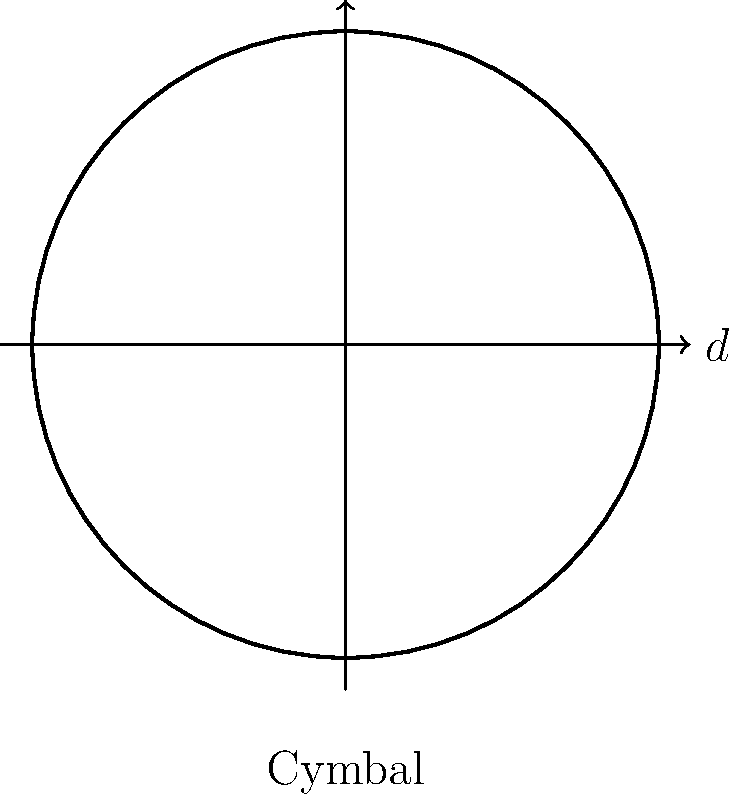Your favorite drummer uses a spherical cymbal with a diameter of 18 inches. Calculate the surface area of this cymbal in square inches. Round your answer to the nearest whole number. To solve this problem, let's follow these steps:

1) First, recall the formula for the surface area of a sphere:
   $$ A = 4\pi r^2 $$
   where $A$ is the surface area and $r$ is the radius.

2) We're given the diameter, which is 18 inches. The radius is half of the diameter:
   $$ r = \frac{d}{2} = \frac{18}{2} = 9 \text{ inches} $$

3) Now, let's substitute this into our formula:
   $$ A = 4\pi (9)^2 $$

4) Simplify:
   $$ A = 4\pi (81) = 324\pi \text{ square inches} $$

5) Using 3.14159 as an approximation for $\pi$:
   $$ A \approx 324 * 3.14159 = 1017.87516 \text{ square inches} $$

6) Rounding to the nearest whole number:
   $$ A \approx 1018 \text{ square inches} $$

Therefore, the surface area of the cymbal is approximately 1018 square inches.
Answer: 1018 square inches 